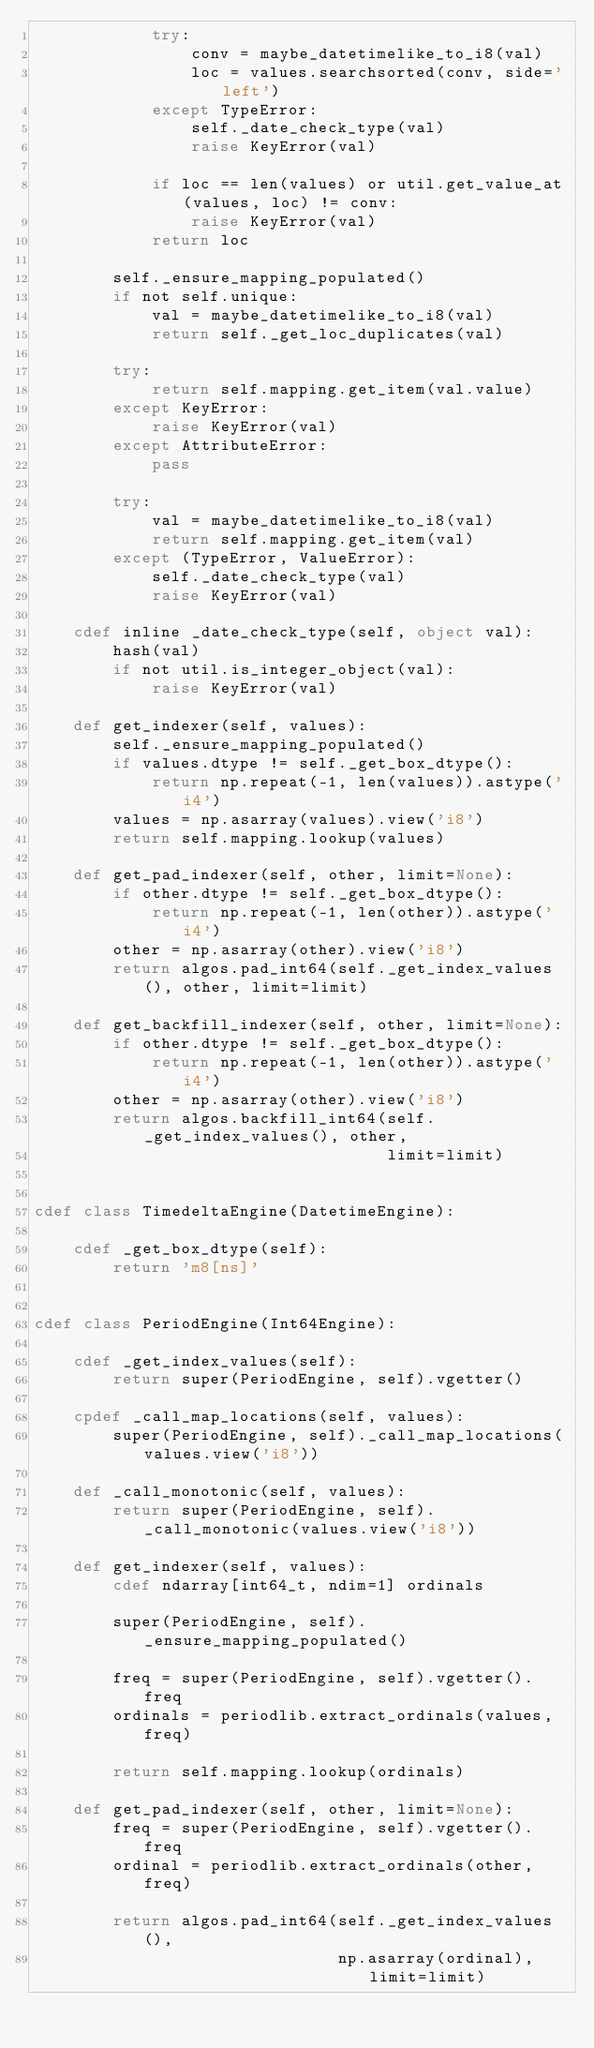<code> <loc_0><loc_0><loc_500><loc_500><_Cython_>            try:
                conv = maybe_datetimelike_to_i8(val)
                loc = values.searchsorted(conv, side='left')
            except TypeError:
                self._date_check_type(val)
                raise KeyError(val)

            if loc == len(values) or util.get_value_at(values, loc) != conv:
                raise KeyError(val)
            return loc

        self._ensure_mapping_populated()
        if not self.unique:
            val = maybe_datetimelike_to_i8(val)
            return self._get_loc_duplicates(val)

        try:
            return self.mapping.get_item(val.value)
        except KeyError:
            raise KeyError(val)
        except AttributeError:
            pass

        try:
            val = maybe_datetimelike_to_i8(val)
            return self.mapping.get_item(val)
        except (TypeError, ValueError):
            self._date_check_type(val)
            raise KeyError(val)

    cdef inline _date_check_type(self, object val):
        hash(val)
        if not util.is_integer_object(val):
            raise KeyError(val)

    def get_indexer(self, values):
        self._ensure_mapping_populated()
        if values.dtype != self._get_box_dtype():
            return np.repeat(-1, len(values)).astype('i4')
        values = np.asarray(values).view('i8')
        return self.mapping.lookup(values)

    def get_pad_indexer(self, other, limit=None):
        if other.dtype != self._get_box_dtype():
            return np.repeat(-1, len(other)).astype('i4')
        other = np.asarray(other).view('i8')
        return algos.pad_int64(self._get_index_values(), other, limit=limit)

    def get_backfill_indexer(self, other, limit=None):
        if other.dtype != self._get_box_dtype():
            return np.repeat(-1, len(other)).astype('i4')
        other = np.asarray(other).view('i8')
        return algos.backfill_int64(self._get_index_values(), other,
                                    limit=limit)


cdef class TimedeltaEngine(DatetimeEngine):

    cdef _get_box_dtype(self):
        return 'm8[ns]'


cdef class PeriodEngine(Int64Engine):

    cdef _get_index_values(self):
        return super(PeriodEngine, self).vgetter()

    cpdef _call_map_locations(self, values):
        super(PeriodEngine, self)._call_map_locations(values.view('i8'))

    def _call_monotonic(self, values):
        return super(PeriodEngine, self)._call_monotonic(values.view('i8'))

    def get_indexer(self, values):
        cdef ndarray[int64_t, ndim=1] ordinals

        super(PeriodEngine, self)._ensure_mapping_populated()

        freq = super(PeriodEngine, self).vgetter().freq
        ordinals = periodlib.extract_ordinals(values, freq)

        return self.mapping.lookup(ordinals)

    def get_pad_indexer(self, other, limit=None):
        freq = super(PeriodEngine, self).vgetter().freq
        ordinal = periodlib.extract_ordinals(other, freq)

        return algos.pad_int64(self._get_index_values(),
                               np.asarray(ordinal), limit=limit)
</code> 